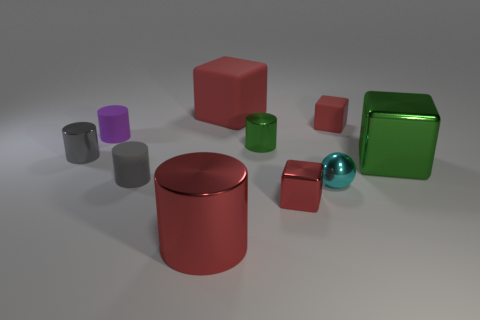Subtract all small gray cylinders. How many cylinders are left? 3 Subtract all green blocks. How many blocks are left? 3 Subtract 2 blocks. How many blocks are left? 2 Subtract all cubes. How many objects are left? 6 Subtract all red cylinders. How many blue cubes are left? 0 Subtract all yellow rubber cubes. Subtract all gray things. How many objects are left? 8 Add 8 cyan balls. How many cyan balls are left? 9 Add 8 big green blocks. How many big green blocks exist? 9 Subtract 0 purple balls. How many objects are left? 10 Subtract all yellow cylinders. Subtract all cyan balls. How many cylinders are left? 5 